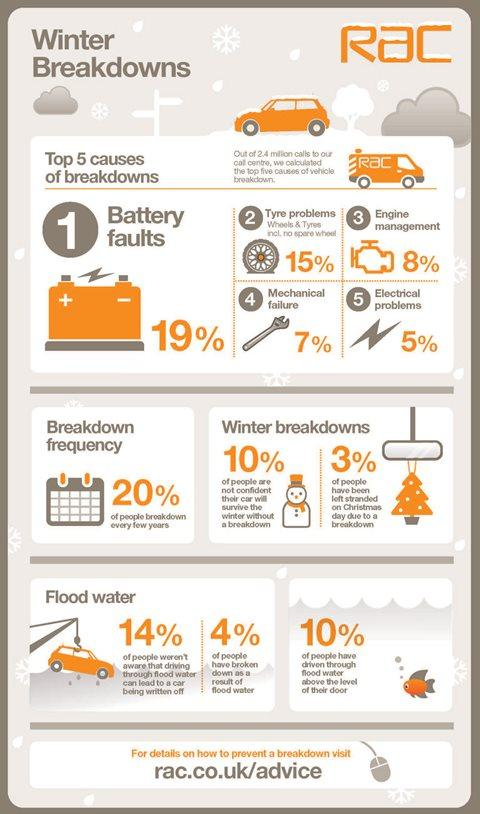Outline some significant characteristics in this image. The color of the Christmas tree is orange, not red. A significant percentage of people have been left stranded on Christmas due to breakdowns. The spanner indicates a possible mechanical failure. The battery indicates the presence of signs such as + and -. The van is covered in a message that reads 'Rac..' 